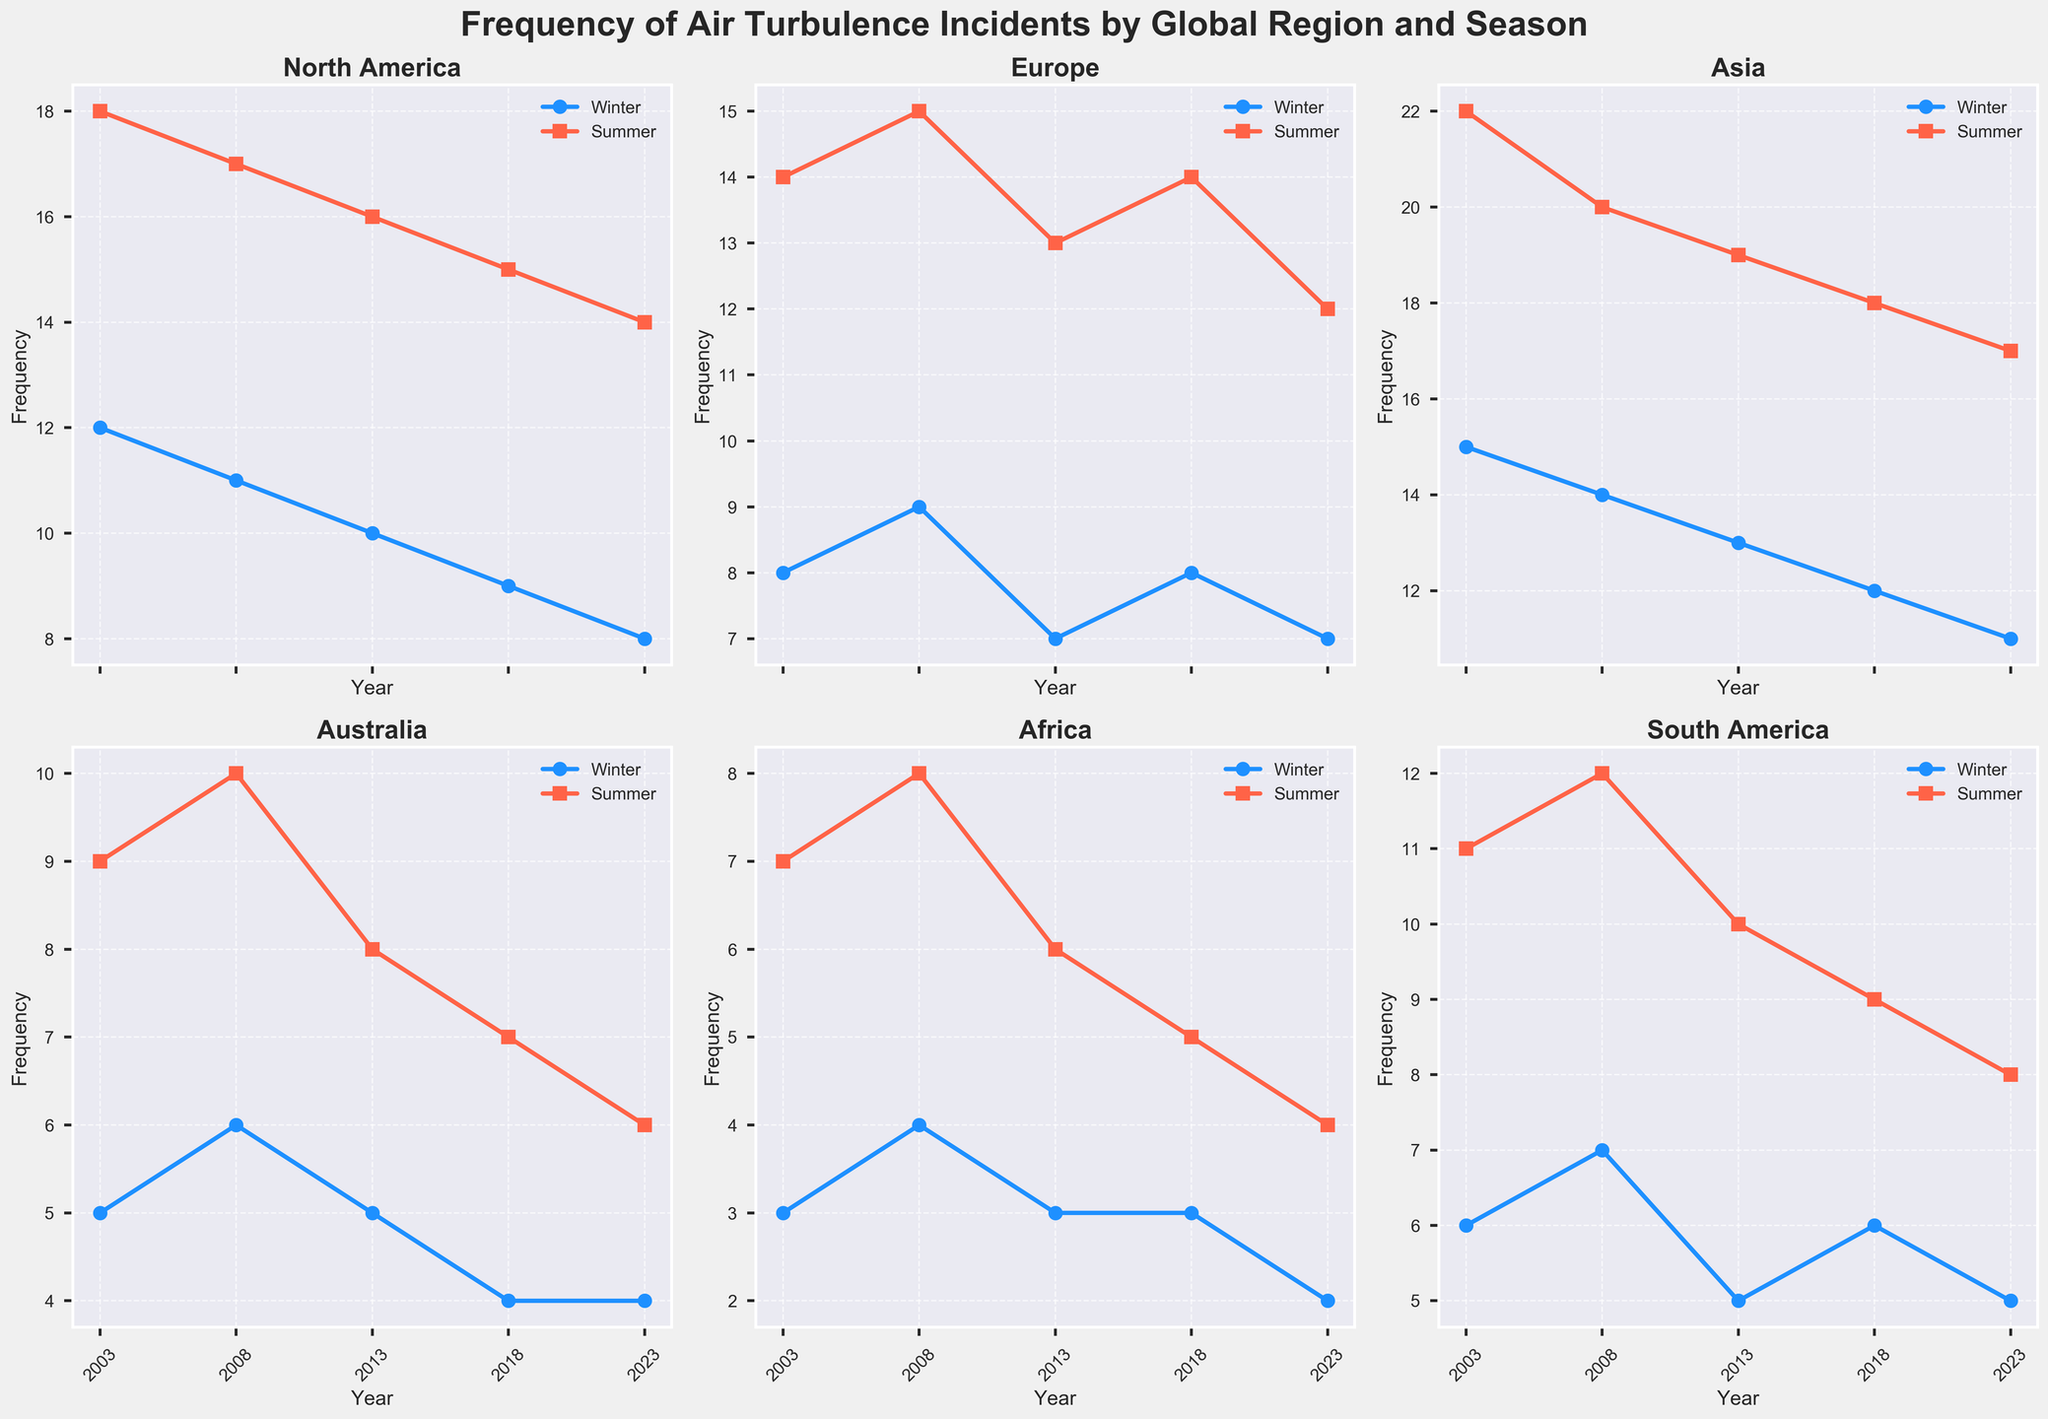What's the general trend of air turbulence incidents in North America during the Winter? Look at the line plot for North America in the Winter season. The number of incidents is decreasing from 2003 to 2023.
Answer: Decreasing Which region had the highest frequency of air turbulence incidents in Summer 2023? Examine each subplot for the Summer of 2023, and identify the highest frequency. Asia has the highest frequency in Summer 2023 with 17 incidents.
Answer: Asia How did the frequency of air turbulence incidents in Europe during Summer change from 2003 to 2023? Check the line plot for Europe during Summer from 2003 to 2023. In 2003, Europe had 14 incidents and in 2023, it had 12 incidents, indicating a slight decrease.
Answer: Decrease Did Asia experience more air turbulence incidents in Winter or Summer, based on the 2023 data? Compare the 2023 Winter and Summer data for Asia. In Winter, Asia had 11 incidents whereas in Summer, it had 17 incidents.
Answer: Summer What is the average frequency of air turbulence incidents in Australia across all seasons over the years shown? Find the frequency of incidents in both Winter and Summer for Australia for each year, sum them and divide by the number of data points (10). (5+9+6+10+5+8+4+7+4+6) / 10 = 6.4.
Answer: 6.4 Between Africa and South America, which region showed a greater reduction in air turbulence incidents from 2003 to 2023 during Winter? Compare the 2003 and 2023 Winter data for both regions. Africa went from 3 to 2 (1 incident reduction), and South America went from 6 to 5 (1 incident reduction). Both regions showed the same reduction.
Answer: Same reduction What is the percentage decrease in the frequency of air turbulence incidents in North America from Winter 2003 to Winter 2023? Calculate the percentage decrease: (12 - 8) / 12 * 100 = 33.33%
Answer: 33.33% Which two regions had an equal number of air turbulence incidents in Winter 2023 and how many incidents were there? Check Winter 2023 data for all regions. Both Europe and South America had 5 incidents each.
Answer: Europe and South America, 5 incidents What is the maximum difference in the frequency of air turbulence incidents between any two seasons in the same year for North America? Look at each year and find the maximum difference between Winter and Summer values in North America. The differences are: 2003 (6), 2008 (6), 2013 (6), 2018 (6), 2023 (6). The maximum difference is consistently 6.
Answer: 6 Did any region show consistent incidents for both seasons in any year, and if so, which year(s) and region(s)? Check if there are any constant values for both seasons of any year. In 2003, Australia had 5 incidents in both Winter and Summer.
Answer: 2003, Australia 